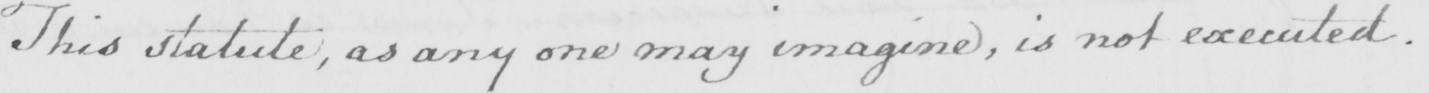What text is written in this handwritten line? This statute , as any one may imagine , is not executed . 